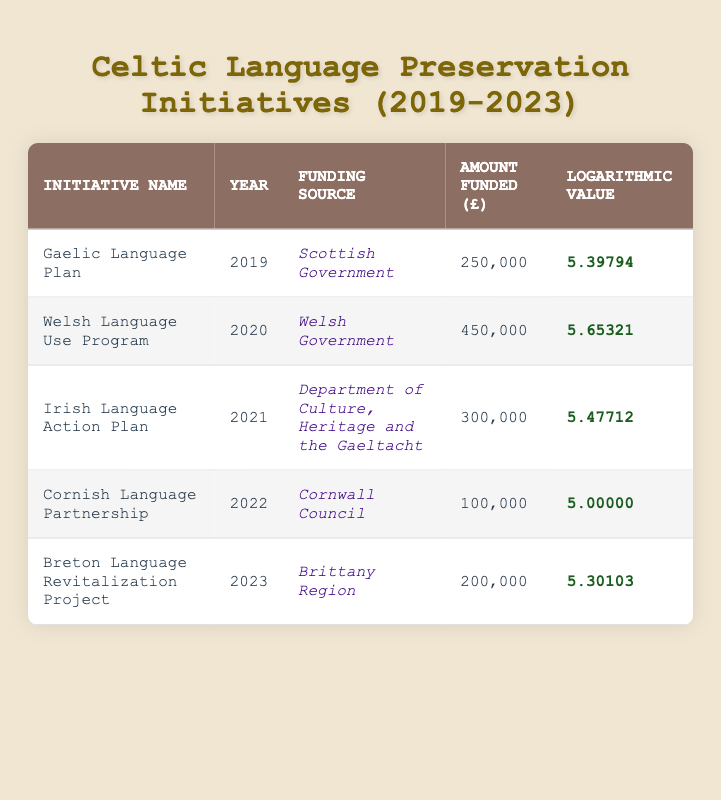What is the most recent initiative listed in the table? The table includes initiatives from 2019 to 2023. To find the most recent initiative, I look for the year 2023 in the Year column. The initiative in that year is the "Breton Language Revitalization Project."
Answer: Breton Language Revitalization Project How much funding was provided for the Welsh Language Use Program? In the table, I locate the row for the "Welsh Language Use Program," then read across to find the value in the Amount Funded column, which is £450,000.
Answer: £450,000 Is the funding for the Cornish Language Partnership greater than £200,000? The Amount Funded for the "Cornish Language Partnership" is £100,000 as seen in the table. Since £100,000 is less than £200,000, the answer to this question is no.
Answer: No Which initiative received the highest amount of funding? To find this, I compare the Amount Funded values across all initiatives. The Welsh Language Use Program has the highest value at £450,000.
Answer: Welsh Language Use Program What are the funding sources for initiatives in 2021 and 2022? I check the Year column for 2021 and 2022. The funding source for the "Irish Language Action Plan" in 2021 is the "Department of Culture, Heritage and the Gaeltacht." In 2022, the "Cornish Language Partnership" received funding from "Cornwall Council." The answer combines both sources.
Answer: Department of Culture, Heritage and the Gaeltacht; Cornwall Council What is the average amount funded across all initiatives? First, I sum the total funding amounts: 250,000 + 450,000 + 300,000 + 100,000 + 200,000 = 1,300,000. Then, dividing this total by the number of initiatives (5) gives 1,300,000 / 5 = 260,000.
Answer: £260,000 Did the funding amount for the Gaelic Language Plan increase from 2019 to 2020? I compare the Amount Funded for both years. The Gaelic Language Plan received £250,000 in 2019 and the Welsh Language Use Program received £450,000 in 2020. Since £450,000 is greater than £250,000, funding did increase.
Answer: Yes Which initiative had a logarithmic value closest to 5.3? I check the Logarithmic Value column for all initiatives. The "Breton Language Revitalization Project" has a logarithmic value of 5.30103, which is the closest to 5.3.
Answer: Breton Language Revitalization Project 